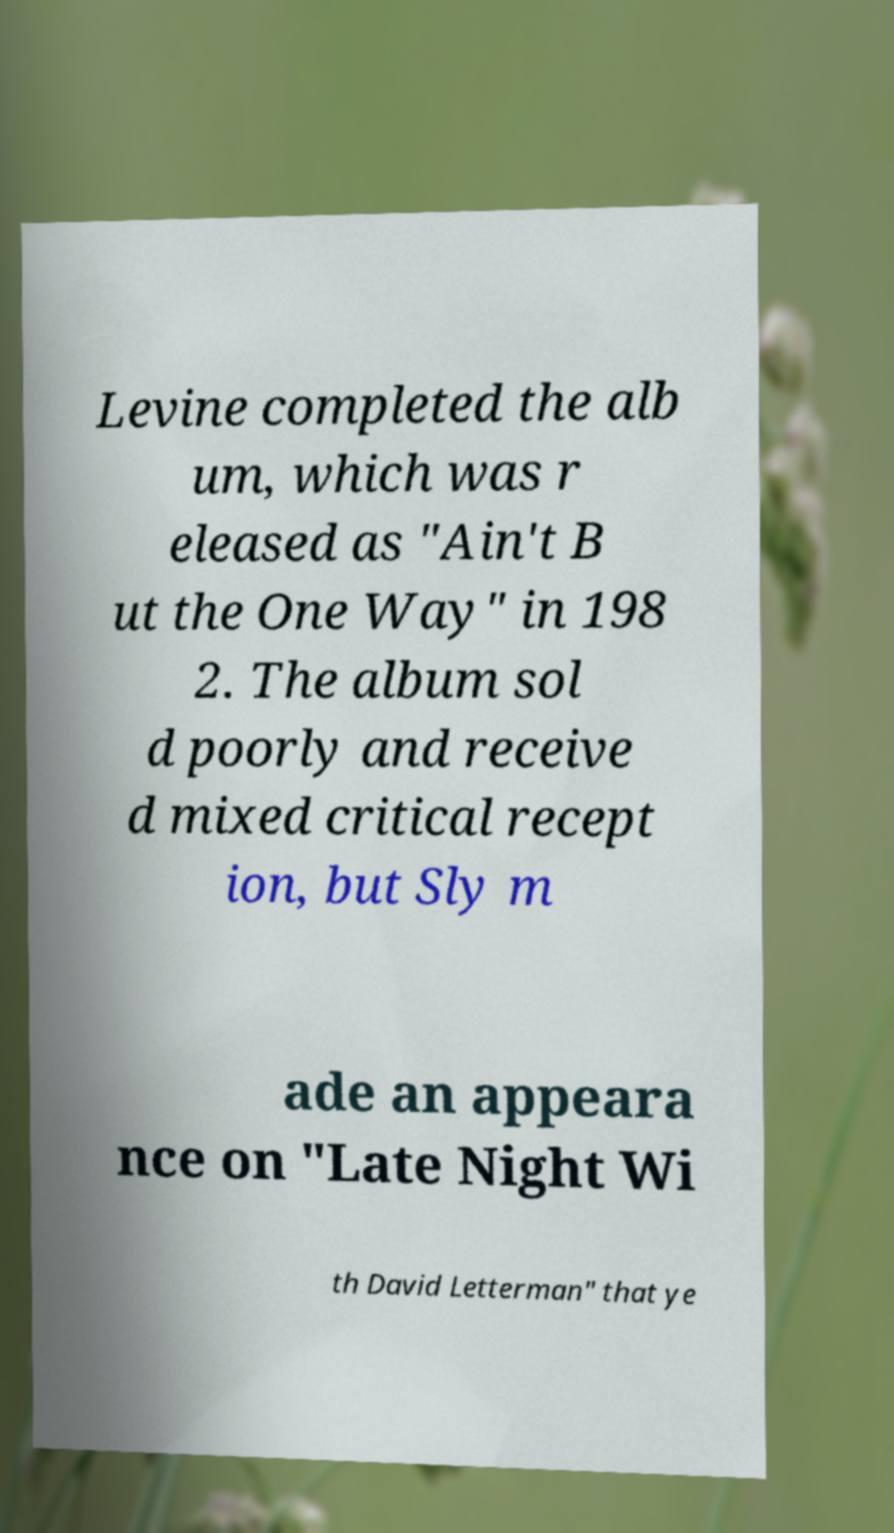What messages or text are displayed in this image? I need them in a readable, typed format. Levine completed the alb um, which was r eleased as "Ain't B ut the One Way" in 198 2. The album sol d poorly and receive d mixed critical recept ion, but Sly m ade an appeara nce on "Late Night Wi th David Letterman" that ye 